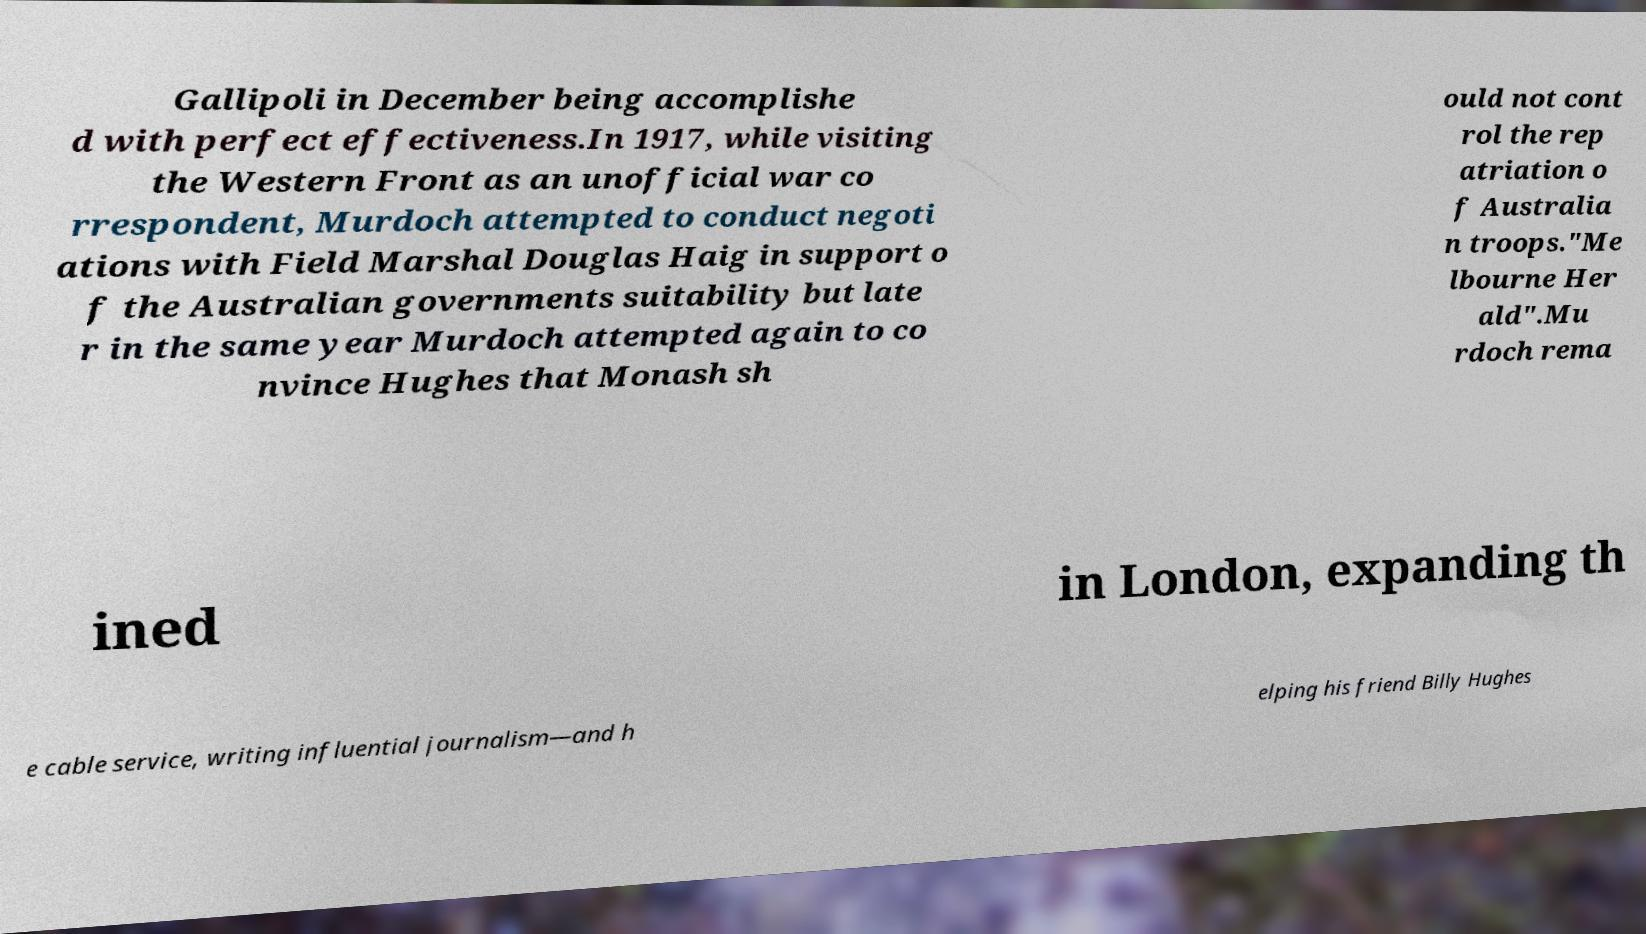I need the written content from this picture converted into text. Can you do that? Gallipoli in December being accomplishe d with perfect effectiveness.In 1917, while visiting the Western Front as an unofficial war co rrespondent, Murdoch attempted to conduct negoti ations with Field Marshal Douglas Haig in support o f the Australian governments suitability but late r in the same year Murdoch attempted again to co nvince Hughes that Monash sh ould not cont rol the rep atriation o f Australia n troops."Me lbourne Her ald".Mu rdoch rema ined in London, expanding th e cable service, writing influential journalism—and h elping his friend Billy Hughes 